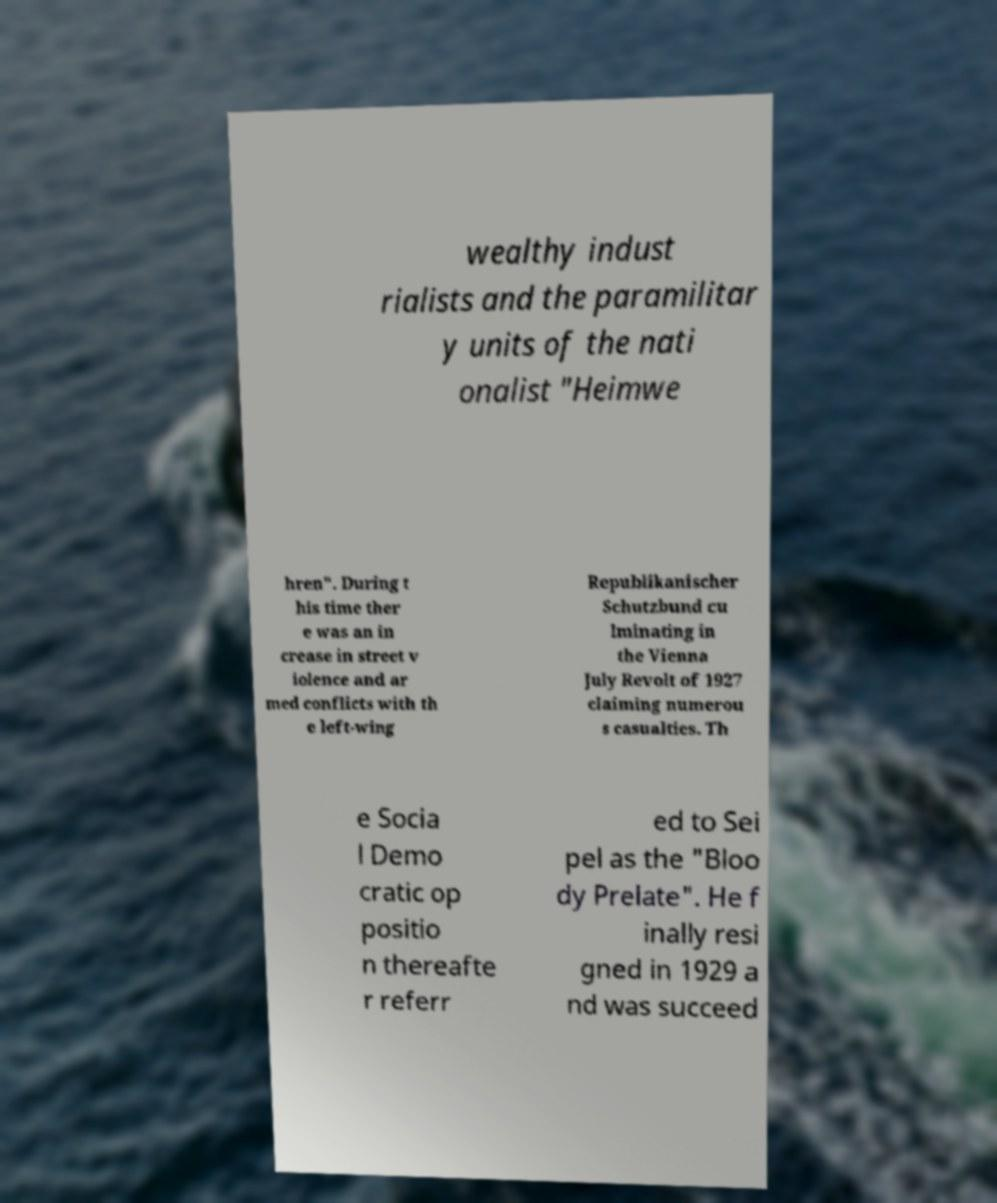Can you read and provide the text displayed in the image?This photo seems to have some interesting text. Can you extract and type it out for me? wealthy indust rialists and the paramilitar y units of the nati onalist "Heimwe hren". During t his time ther e was an in crease in street v iolence and ar med conflicts with th e left-wing Republikanischer Schutzbund cu lminating in the Vienna July Revolt of 1927 claiming numerou s casualties. Th e Socia l Demo cratic op positio n thereafte r referr ed to Sei pel as the "Bloo dy Prelate". He f inally resi gned in 1929 a nd was succeed 